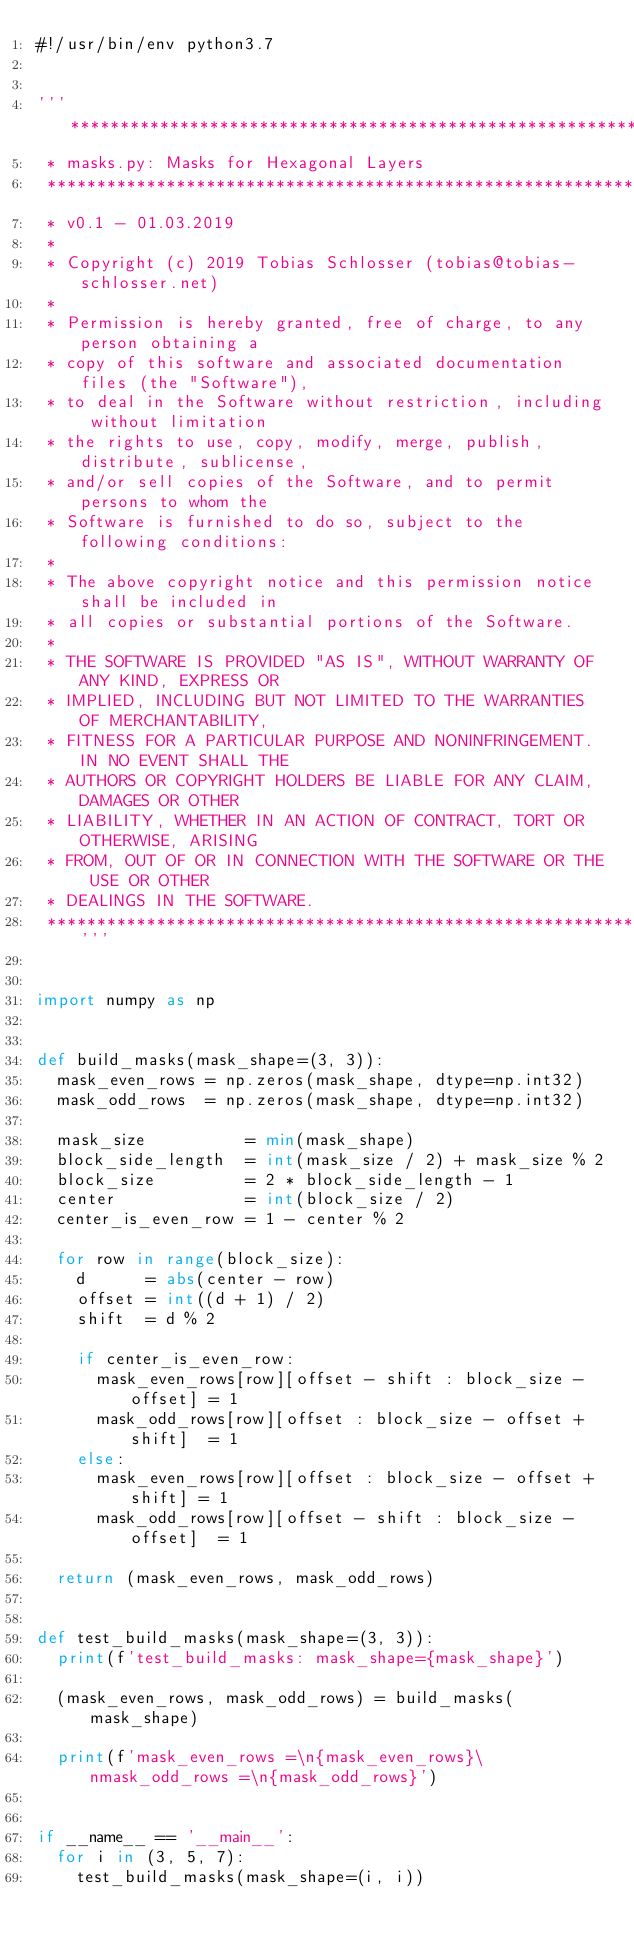<code> <loc_0><loc_0><loc_500><loc_500><_Python_>#!/usr/bin/env python3.7


'''****************************************************************************
 * masks.py: Masks for Hexagonal Layers
 ******************************************************************************
 * v0.1 - 01.03.2019
 *
 * Copyright (c) 2019 Tobias Schlosser (tobias@tobias-schlosser.net)
 *
 * Permission is hereby granted, free of charge, to any person obtaining a
 * copy of this software and associated documentation files (the "Software"),
 * to deal in the Software without restriction, including without limitation
 * the rights to use, copy, modify, merge, publish, distribute, sublicense,
 * and/or sell copies of the Software, and to permit persons to whom the
 * Software is furnished to do so, subject to the following conditions:
 *
 * The above copyright notice and this permission notice shall be included in
 * all copies or substantial portions of the Software.
 *
 * THE SOFTWARE IS PROVIDED "AS IS", WITHOUT WARRANTY OF ANY KIND, EXPRESS OR
 * IMPLIED, INCLUDING BUT NOT LIMITED TO THE WARRANTIES OF MERCHANTABILITY,
 * FITNESS FOR A PARTICULAR PURPOSE AND NONINFRINGEMENT. IN NO EVENT SHALL THE
 * AUTHORS OR COPYRIGHT HOLDERS BE LIABLE FOR ANY CLAIM, DAMAGES OR OTHER
 * LIABILITY, WHETHER IN AN ACTION OF CONTRACT, TORT OR OTHERWISE, ARISING
 * FROM, OUT OF OR IN CONNECTION WITH THE SOFTWARE OR THE USE OR OTHER
 * DEALINGS IN THE SOFTWARE.
 ****************************************************************************'''


import numpy as np


def build_masks(mask_shape=(3, 3)):
	mask_even_rows = np.zeros(mask_shape, dtype=np.int32)
	mask_odd_rows  = np.zeros(mask_shape, dtype=np.int32)

	mask_size          = min(mask_shape)
	block_side_length  = int(mask_size / 2) + mask_size % 2
	block_size         = 2 * block_side_length - 1
	center             = int(block_size / 2)
	center_is_even_row = 1 - center % 2

	for row in range(block_size):
		d      = abs(center - row)
		offset = int((d + 1) / 2)
		shift  = d % 2

		if center_is_even_row:
			mask_even_rows[row][offset - shift : block_size - offset] = 1
			mask_odd_rows[row][offset : block_size - offset + shift]  = 1
		else:
			mask_even_rows[row][offset : block_size - offset + shift] = 1
			mask_odd_rows[row][offset - shift : block_size - offset]  = 1

	return (mask_even_rows, mask_odd_rows)


def test_build_masks(mask_shape=(3, 3)):
	print(f'test_build_masks: mask_shape={mask_shape}')

	(mask_even_rows, mask_odd_rows) = build_masks(mask_shape)

	print(f'mask_even_rows =\n{mask_even_rows}\nmask_odd_rows =\n{mask_odd_rows}')


if __name__ == '__main__':
	for i in (3, 5, 7):
		test_build_masks(mask_shape=(i, i))


</code> 